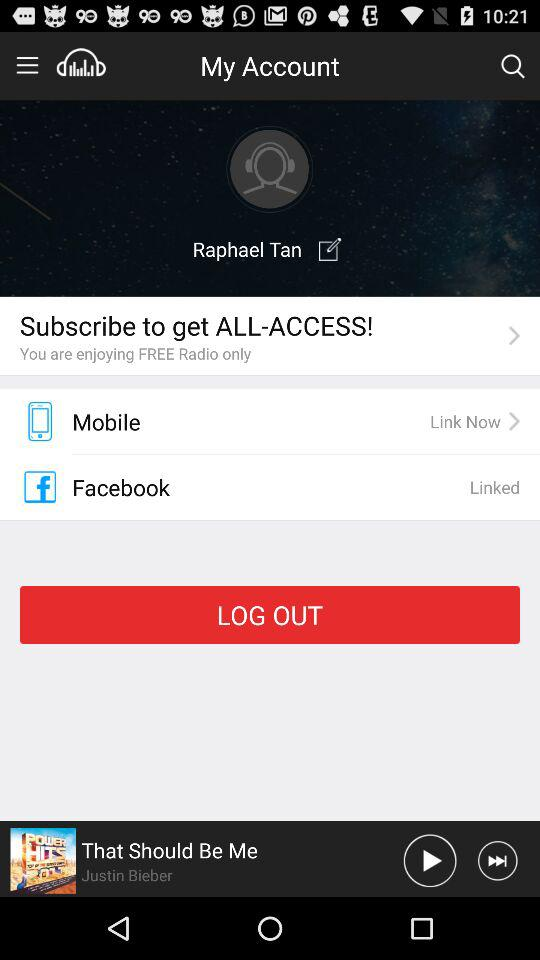Who is the singer of the song? The singer of the song is Justin Bieber. 